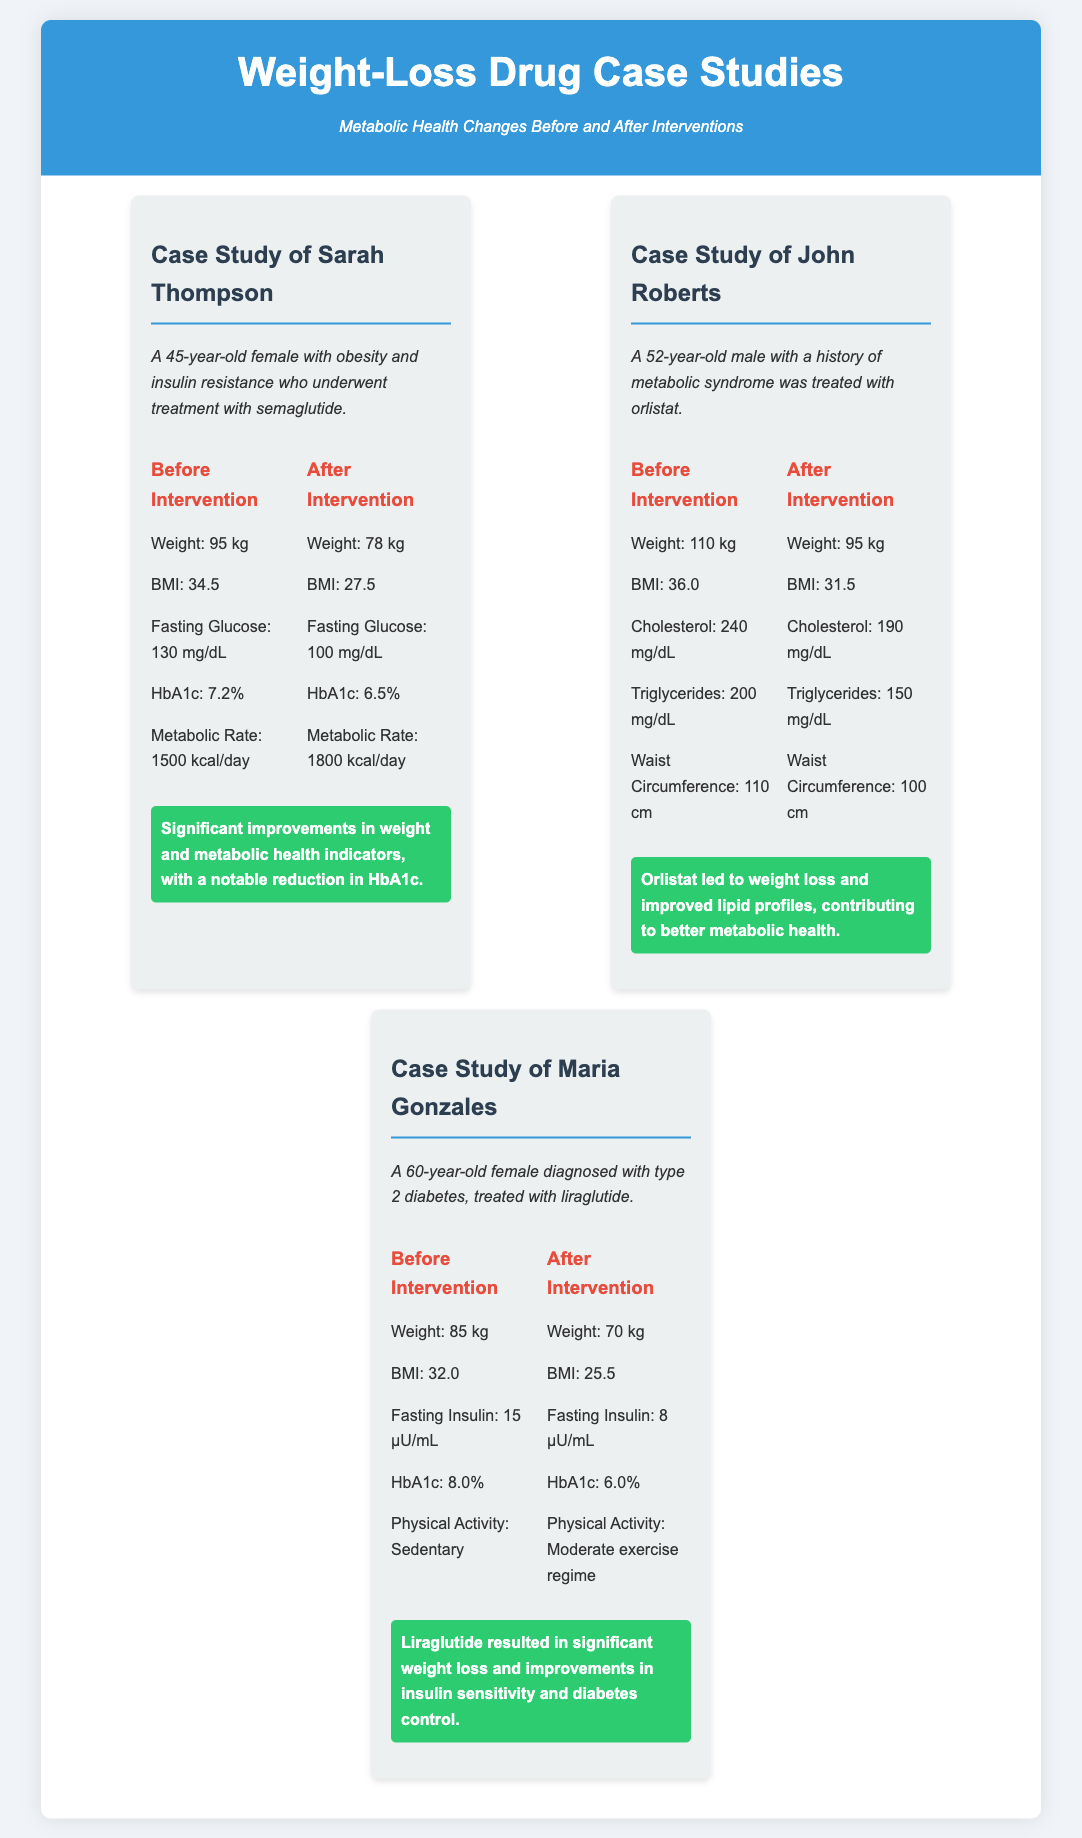What is the age of Sarah Thompson? Sarah Thompson is introduced as a 45-year-old female in the case study.
Answer: 45 years old What drug was used in John Roberts' treatment? John Roberts was treated with orlistat as indicated in the case study.
Answer: Orlistat What was Maria Gonzales' HbA1c level before intervention? The document states that Maria Gonzales had an HbA1c level of 8.0% before her treatment.
Answer: 8.0% What improvement in waist circumference did John Roberts experience? The before and after data shows a reduction in waist circumference from 110 cm to 100 cm.
Answer: 10 cm What metabolic indicator improved significantly for Sarah Thompson? The significant improvement noted is in her HbA1c level, which decreased from 7.2% to 6.5%.
Answer: HbA1c Which case study involved a patient diagnosed with type 2 diabetes? The case study of Maria Gonzales specifies that she was diagnosed with type 2 diabetes.
Answer: Maria Gonzales What was Maria Gonzales' physical activity level after treatment? After treatment, Maria Gonzales is described as having a moderate exercise regime.
Answer: Moderate exercise regime How much weight did Sarah Thompson lose after the intervention? Sarah Thompson lost 17 kg, decreasing from 95 kg to 78 kg.
Answer: 17 kg 